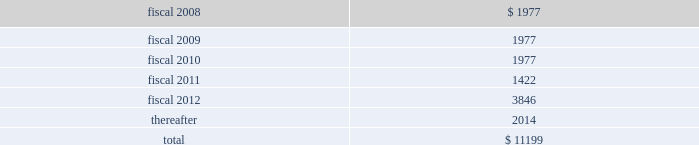Hologic , inc .
Notes to consolidated financial statements ( continued ) ( in thousands , except per share data ) future debt principal payments under these debt arrangements are approximately as follows: .
Derivative financial instruments and hedging agreements interest rate swaps in connection with the debt assumed from the aeg acquisition ( see notes 3 and 5 ) , the company acquired interest rate swap contracts used to convert the floating interest-rate component of certain debt obligations to fixed rates .
These agreements did not qualify for hedge accounting under statements of financial accounting standards no .
133 , accounting for derivative instruments and hedging activities ( 201csfas 133 201d ) and thus were marked to market each reporting period with the change in fair value recorded to other income ( expense ) , net in the accompanying consolidated statements of income .
The company terminated all outstanding interest rate swaps in the fourth quarter of fiscal 2007 which resulted in a gain of $ 75 recorded in consolidated statement of income .
Forward contracts also in connection with the aeg acquisition , the company assumed certain foreign currency forward contracts to hedge , on a net basis , the foreign currency fluctuations associated with a portion of the aeg 2019s assets and liabilities that were denominated in the us dollar , including inter-company accounts .
Increases or decreases in the company 2019s foreign currency exposures are partially offset by gains and losses on the forward contracts , so as to mitigate foreign currency transaction gains and losses .
The terms of these forward contracts are of a short- term nature ( 6 to 12 months ) .
The company does not use forward contracts for trading or speculative purposes .
The forward contracts are not designated as cash flow or fair value hedges under sfas no .
133 and do not represent effective hedges .
All outstanding forward contracts are marked to market at the end of the period and recorded on the balance sheet at fair value in other current assets and other current liabilities .
The changes in fair value from these contracts and from the underlying hedged exposures are generally offsetting were recorded in other income , net in the accompanying consolidated statements of income and these amounts were not material .
As of september 29 , 2007 , all of the forward exchange contracts assumed in the aeg acquisition had matured and the company had no forward exchange contracts outstanding .
Pension and other employee benefits in conjunction with the may 2 , 2006 acquisition of aeg , the company assumed certain defined benefit pension plans covering the employees of the aeg german subsidiary ( pension benefits ) .
On september 29 , 2006 , the fasb issued sfas no .
158 , employers 2019 accounting for defined benefit pension and other postretirement plans , an amendment of fasb statements no .
87 , 88 , 106 and 132 ( r ) ( sfas 158 ) .
Sfas 158 requires an entity to recognize in its statement of financial position an asset for a defined benefit postretirement .
What portion of the total future debt is reported under the current liabilities section of the balance sheet as of the end of fiscal 2007? 
Computations: (1977 / 11199)
Answer: 0.17653. 